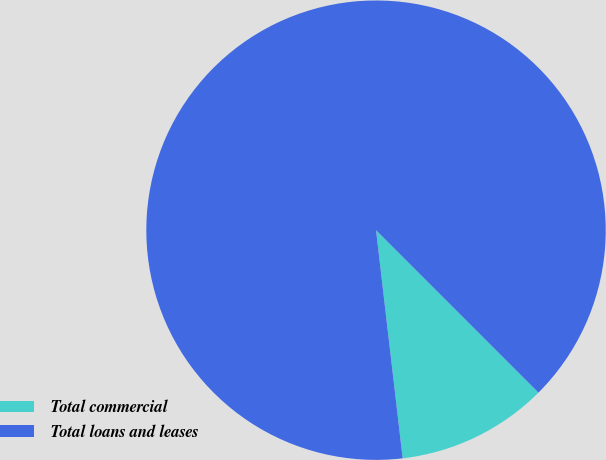Convert chart to OTSL. <chart><loc_0><loc_0><loc_500><loc_500><pie_chart><fcel>Total commercial<fcel>Total loans and leases<nl><fcel>10.65%<fcel>89.35%<nl></chart> 